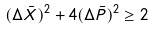Convert formula to latex. <formula><loc_0><loc_0><loc_500><loc_500>( \Delta \bar { X } ) ^ { 2 } + 4 ( \Delta \bar { P } ) ^ { 2 } \geq 2</formula> 